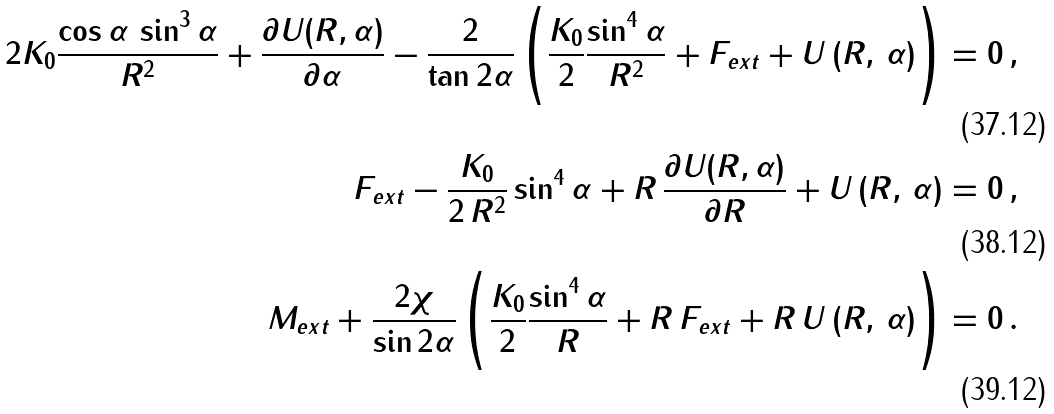<formula> <loc_0><loc_0><loc_500><loc_500>2 K _ { 0 } \frac { \cos \alpha \, \sin ^ { 3 } \alpha } { R ^ { 2 } } + \frac { \partial U ( R , \alpha ) } { \partial \alpha } - \frac { 2 } { \tan 2 \alpha } \left ( \frac { K _ { 0 } } { 2 } \frac { \sin ^ { 4 } \alpha } { R ^ { 2 } } + F _ { e x t } + U \, ( R , \, \alpha ) \right ) & = 0 \, , \\ F _ { e x t } - \frac { K _ { 0 } } { 2 \, R ^ { 2 } } \sin ^ { 4 } \alpha + R \, \frac { \partial U ( R , \alpha ) } { \partial R } + U \, ( R , \, \alpha ) & = 0 \, , \\ M _ { e x t } + \frac { 2 \chi } { \sin 2 \alpha } \left ( \frac { K _ { 0 } } { 2 } \frac { \sin ^ { 4 } \alpha } { R } + R \, F _ { e x t } + R \, U \, ( R , \, \alpha ) \right ) & = 0 \, .</formula> 